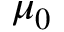<formula> <loc_0><loc_0><loc_500><loc_500>\mu _ { 0 }</formula> 